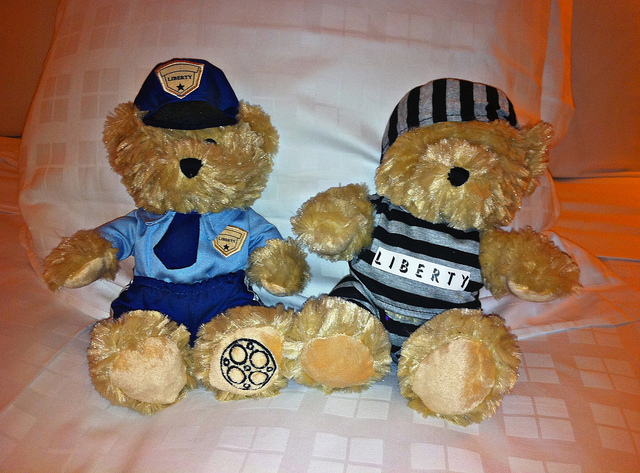Extract all visible text content from this image. LIBERTY LIBERTY 